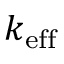Convert formula to latex. <formula><loc_0><loc_0><loc_500><loc_500>k _ { e f f }</formula> 